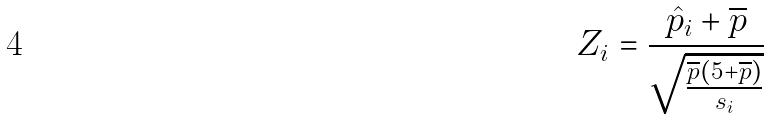<formula> <loc_0><loc_0><loc_500><loc_500>Z _ { i } = \frac { \hat { p } _ { i } + \overline { p } } { \sqrt { \frac { \overline { p } ( 5 + \overline { p } ) } { s _ { i } } } }</formula> 